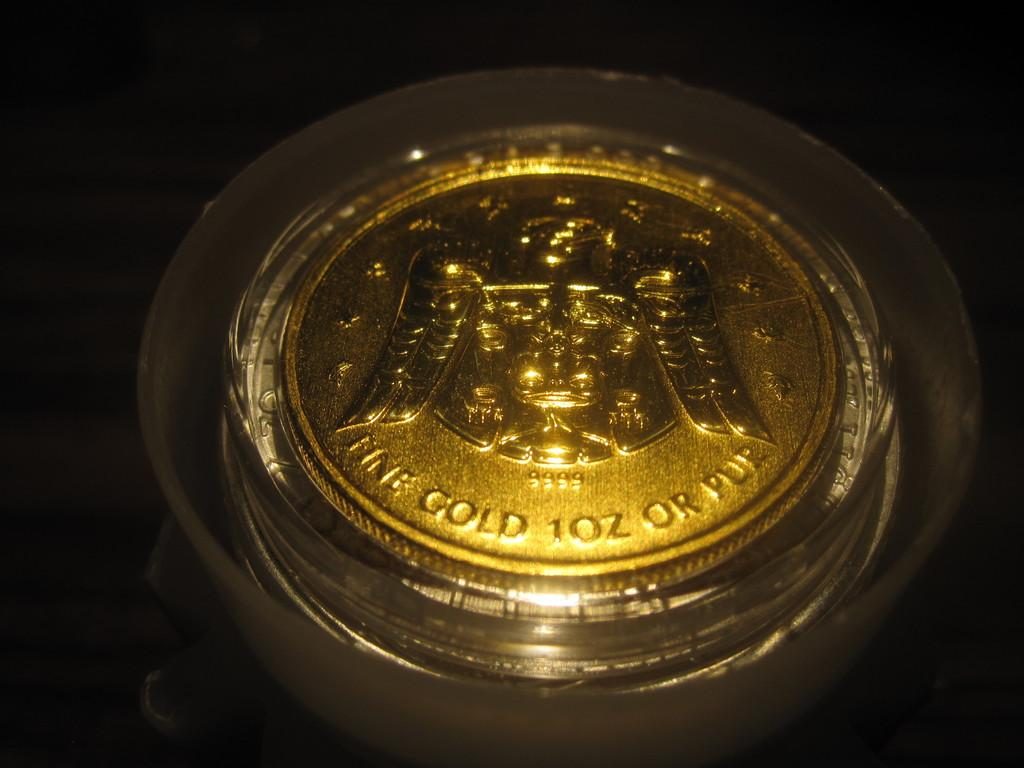Provide a one-sentence caption for the provided image. Golden coin that says "Fine Gold 1oz or Pur". 